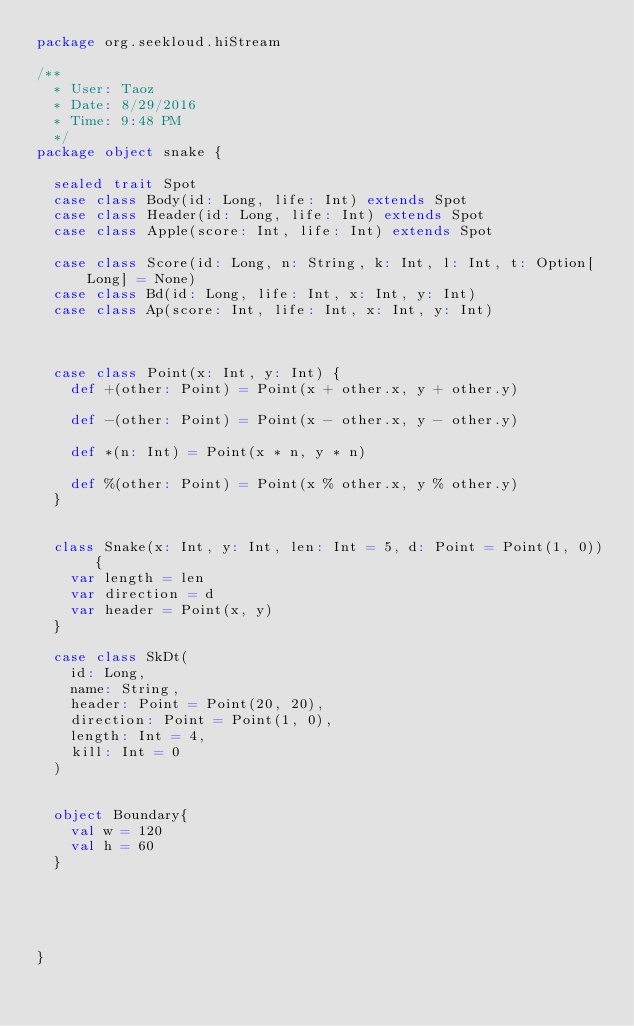<code> <loc_0><loc_0><loc_500><loc_500><_Scala_>package org.seekloud.hiStream

/**
  * User: Taoz
  * Date: 8/29/2016
  * Time: 9:48 PM
  */
package object snake {

  sealed trait Spot
  case class Body(id: Long, life: Int) extends Spot
  case class Header(id: Long, life: Int) extends Spot
  case class Apple(score: Int, life: Int) extends Spot

  case class Score(id: Long, n: String, k: Int, l: Int, t: Option[Long] = None)
  case class Bd(id: Long, life: Int, x: Int, y: Int)
  case class Ap(score: Int, life: Int, x: Int, y: Int)



  case class Point(x: Int, y: Int) {
    def +(other: Point) = Point(x + other.x, y + other.y)

    def -(other: Point) = Point(x - other.x, y - other.y)

    def *(n: Int) = Point(x * n, y * n)

    def %(other: Point) = Point(x % other.x, y % other.y)
  }


  class Snake(x: Int, y: Int, len: Int = 5, d: Point = Point(1, 0)) {
    var length = len
    var direction = d
    var header = Point(x, y)
  }

  case class SkDt(
    id: Long,
    name: String,
    header: Point = Point(20, 20),
    direction: Point = Point(1, 0),
    length: Int = 4,
    kill: Int = 0
  )


  object Boundary{
    val w = 120
    val h = 60
  }





}
</code> 